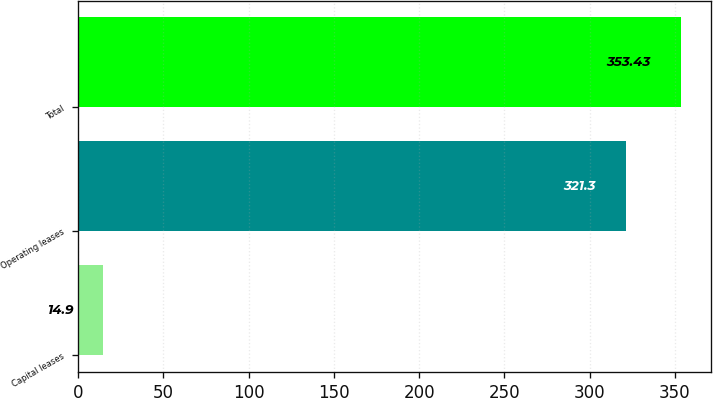<chart> <loc_0><loc_0><loc_500><loc_500><bar_chart><fcel>Capital leases<fcel>Operating leases<fcel>Total<nl><fcel>14.9<fcel>321.3<fcel>353.43<nl></chart> 